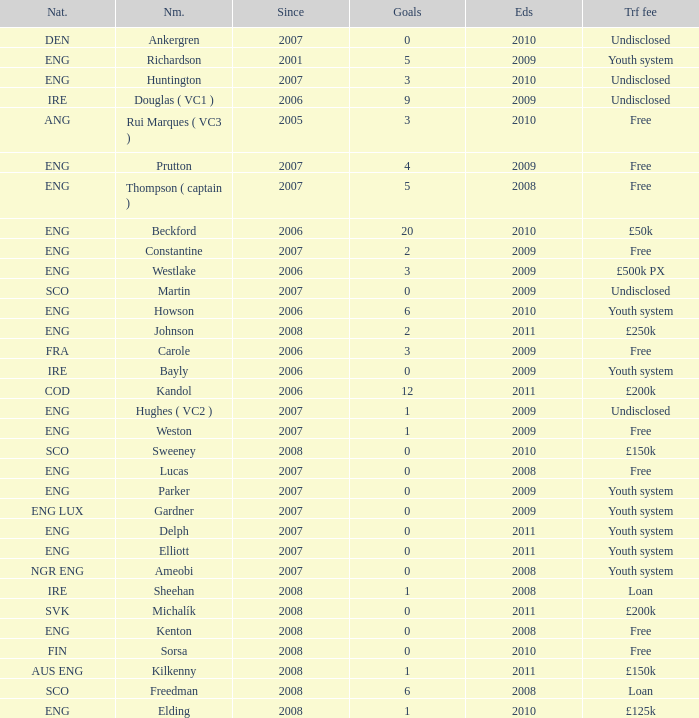Name the average ends for weston 2009.0. 